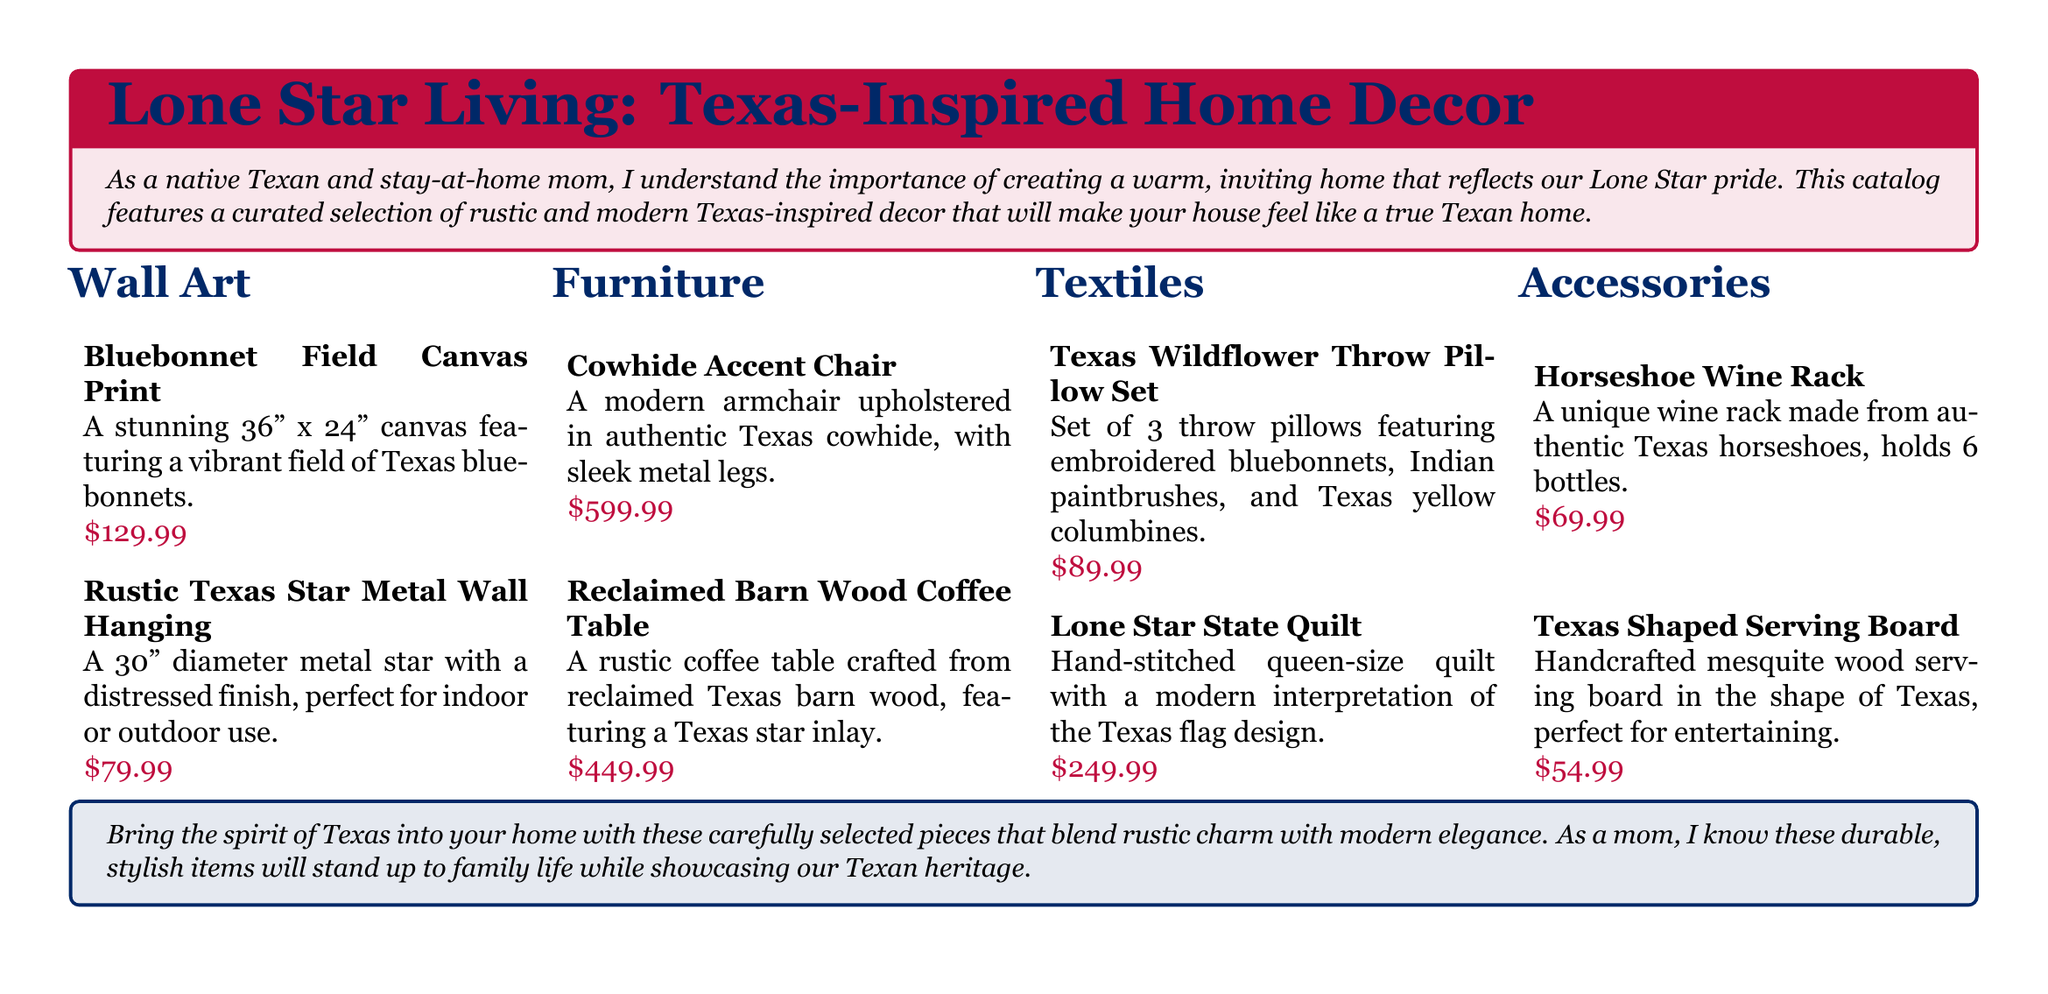what is the price of the Bluebonnet Field Canvas Print? The price of the Bluebonnet Field Canvas Print is specified in the document.
Answer: $129.99 how many items are listed under Accessories? By counting the items mentioned in the Accessories section of the document, we can determine the total.
Answer: 2 what is the size of the Lone Star State Quilt? The document states that the Lone Star State Quilt is a queen-size quilt.
Answer: queen-size what material is the Cowhide Accent Chair made of? The document describes the Cowhide Accent Chair and its upholstery material.
Answer: authentic Texas cowhide which item features a Texas star inlay? The Reclaimed Barn Wood Coffee Table is specifically mentioned to have a Texas star inlay.
Answer: Reclaimed Barn Wood Coffee Table how many throw pillows are included in the Texas Wildflower Throw Pillow Set? The document indicates the number of pillows in the Texas Wildflower Throw Pillow Set.
Answer: 3 what color is the background of the tcolorbox that introduces the catalog? The color of the background of the tcolorbox is described in the document.
Answer: texasred!10 which furniture item has sleek metal legs? The Cowhide Accent Chair is highlighted for its design and unique features mentioned.
Answer: Cowhide Accent Chair 